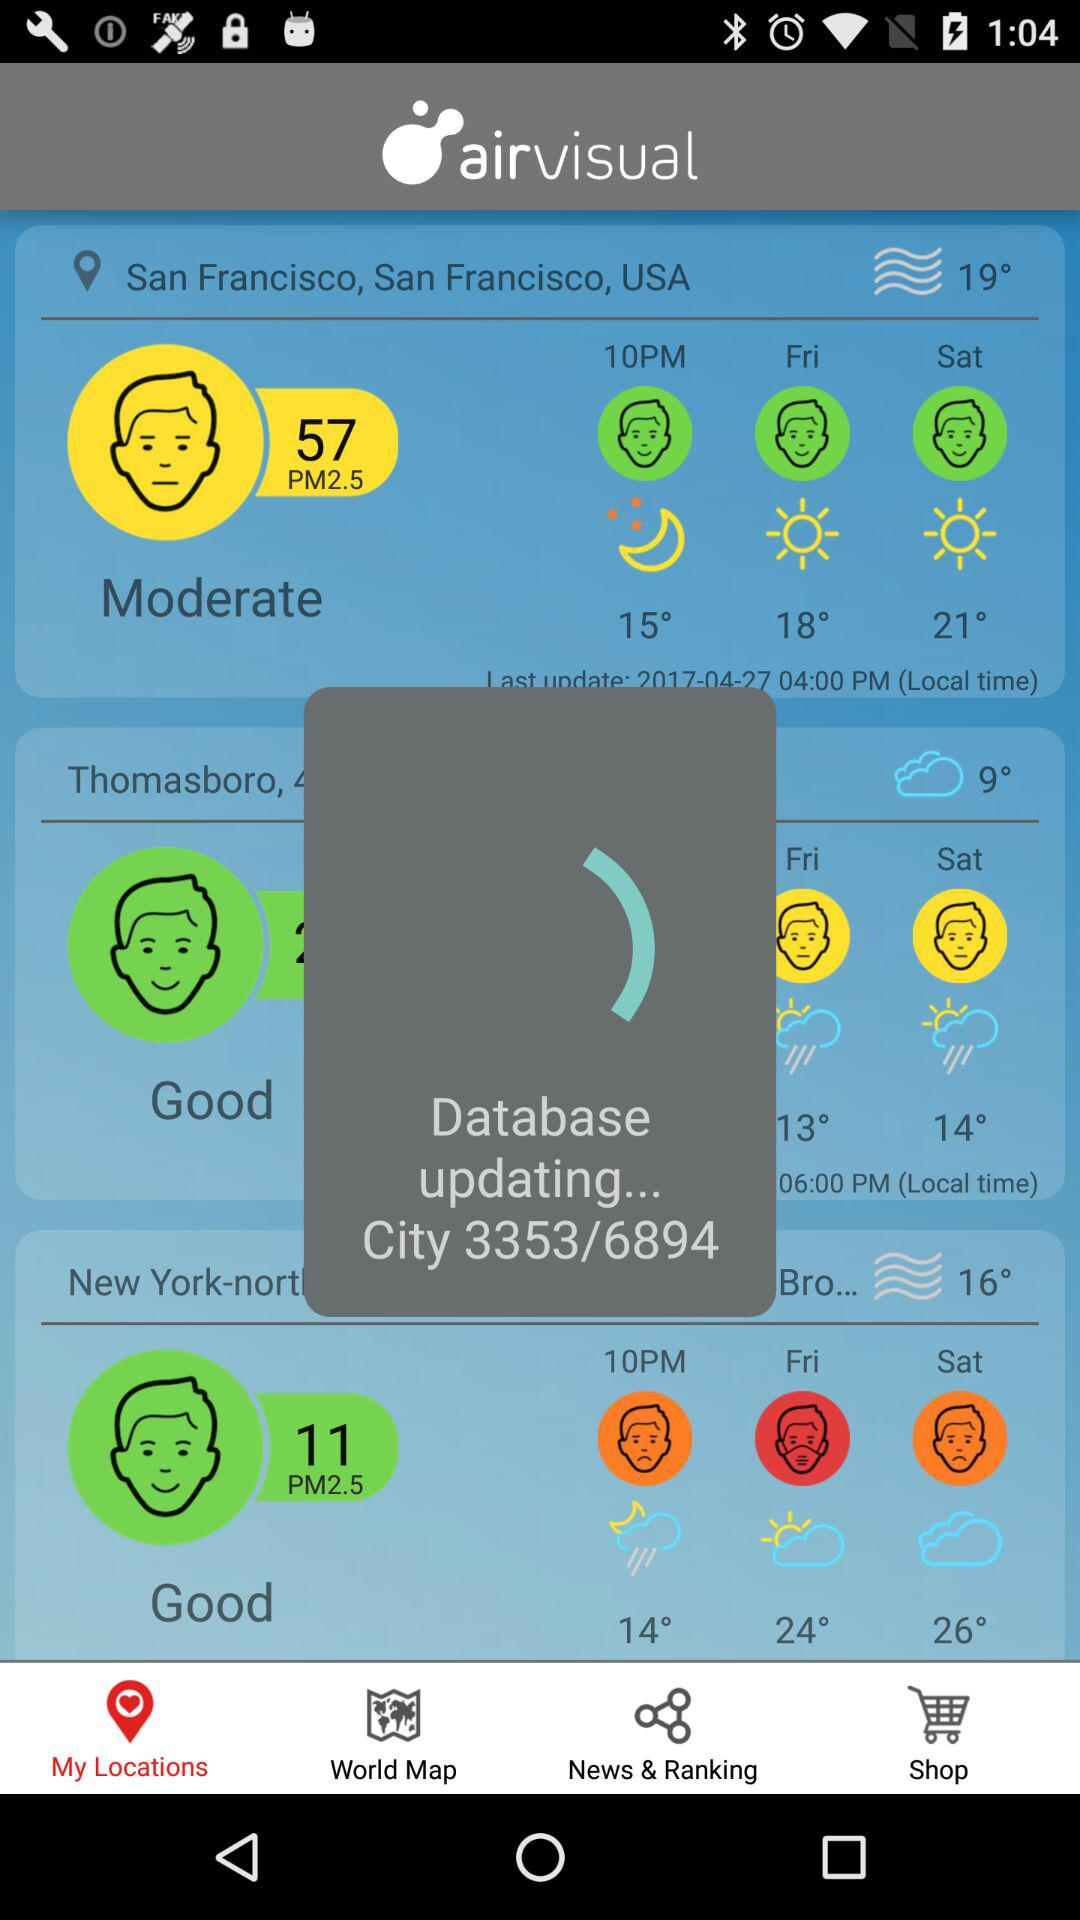What is the status of "Database"? The status of "Database" is "updating...". 